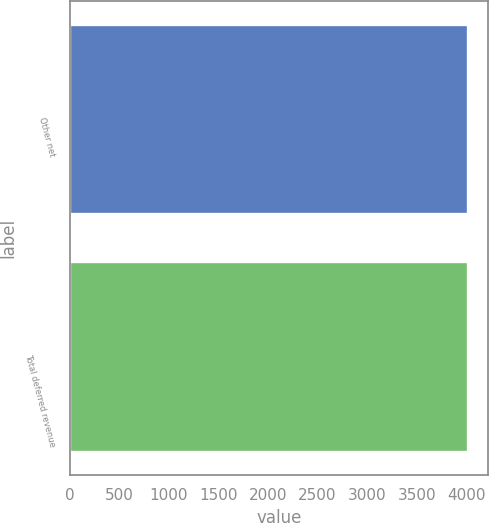Convert chart. <chart><loc_0><loc_0><loc_500><loc_500><bar_chart><fcel>Other net<fcel>Total deferred revenue<nl><fcel>4019<fcel>4019.1<nl></chart> 